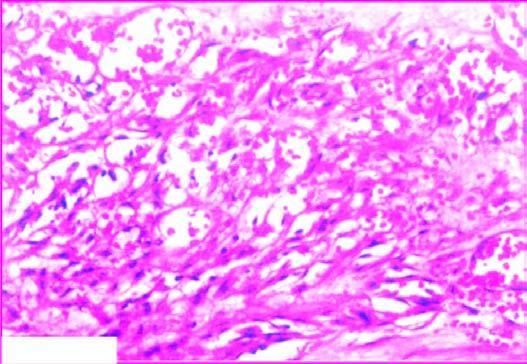re there slit-like blood-filled vascular spaces?
Answer the question using a single word or phrase. Yes 